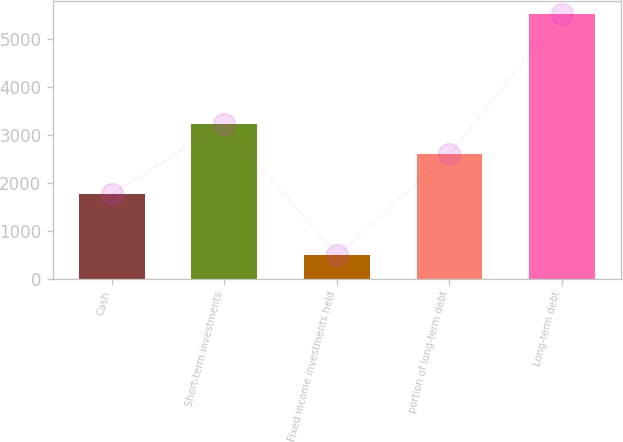Convert chart to OTSL. <chart><loc_0><loc_0><loc_500><loc_500><bar_chart><fcel>Cash<fcel>Short-term investments<fcel>Fixed income investments held<fcel>portion of long-term debt<fcel>Long-term debt<nl><fcel>1764<fcel>3226<fcel>484<fcel>2595<fcel>5517<nl></chart> 